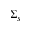Convert formula to latex. <formula><loc_0><loc_0><loc_500><loc_500>\Sigma _ { s }</formula> 